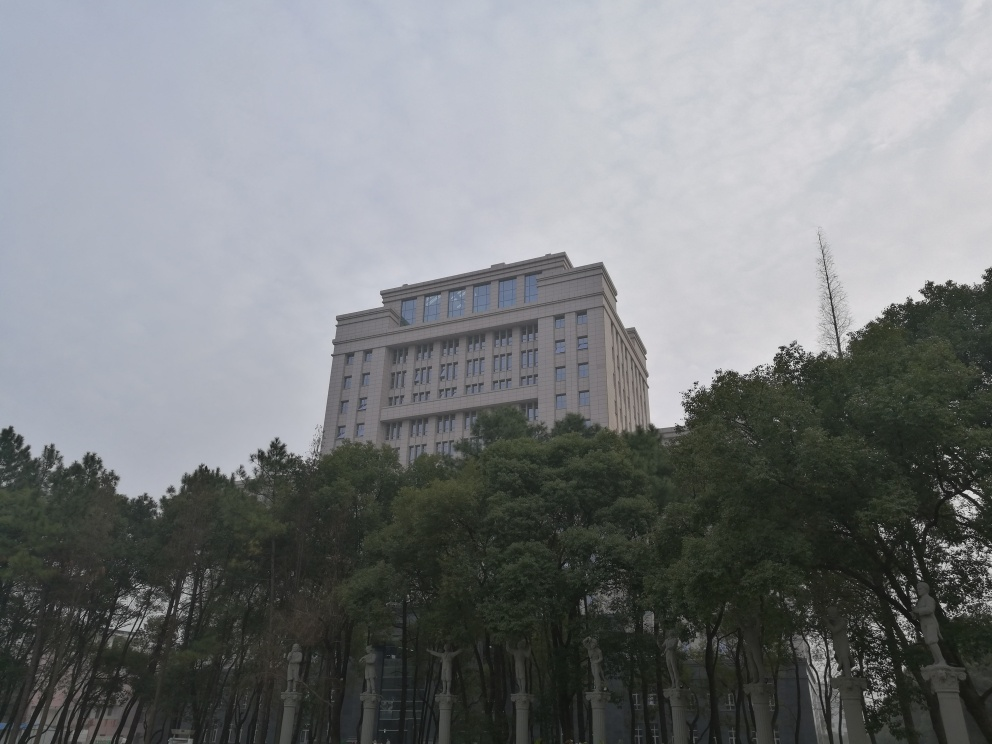Is there any specific distortion in this image? Upon reviewing the image, it appears to exhibit no significant distortions. The proportions of the building, trees, and surrounding elements are consistent with natural perspective. The photo seems to have been taken with a steady hand or a stable surface, and there's no evidence of warping or other common distortions that can occur with certain lens types or editing methods. Overall, the image appears to be a straightforward representation of the scene. 